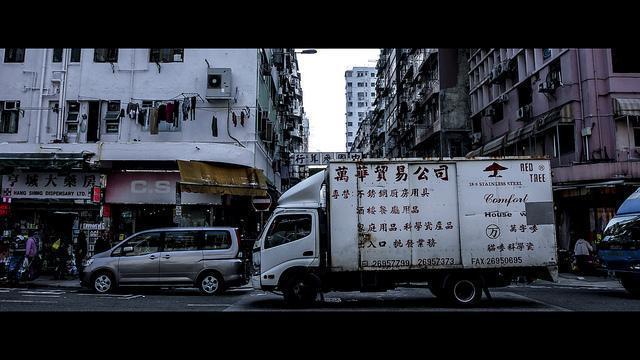How many vehicles are in this image?
Give a very brief answer. 3. 